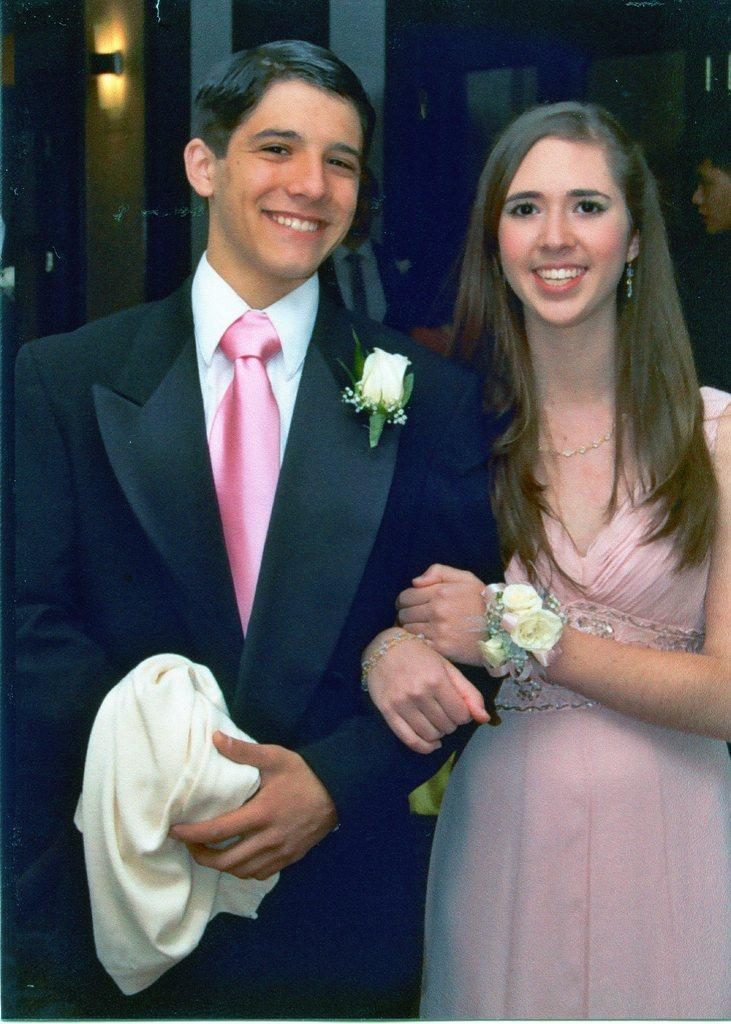How many people are in the image? There are two people in the image, a man and a woman. What are the man and woman doing in the image? Both the man and woman are posing for a camera. What is the man wearing in the image? The man is wearing a suit. What is the man holding in the image? The man is holding a cloth with his hands. What can be seen on the man's suit? There is a flower on the man's suit. What expression do the man and woman have in the image? The man and woman are smiling. What type of steel is visible on the man's suit in the image? There is no steel visible on the man's suit in the image. How many teeth can be seen in the man's smile in the image? The image does not show individual teeth; it only shows the man and woman smiling. 